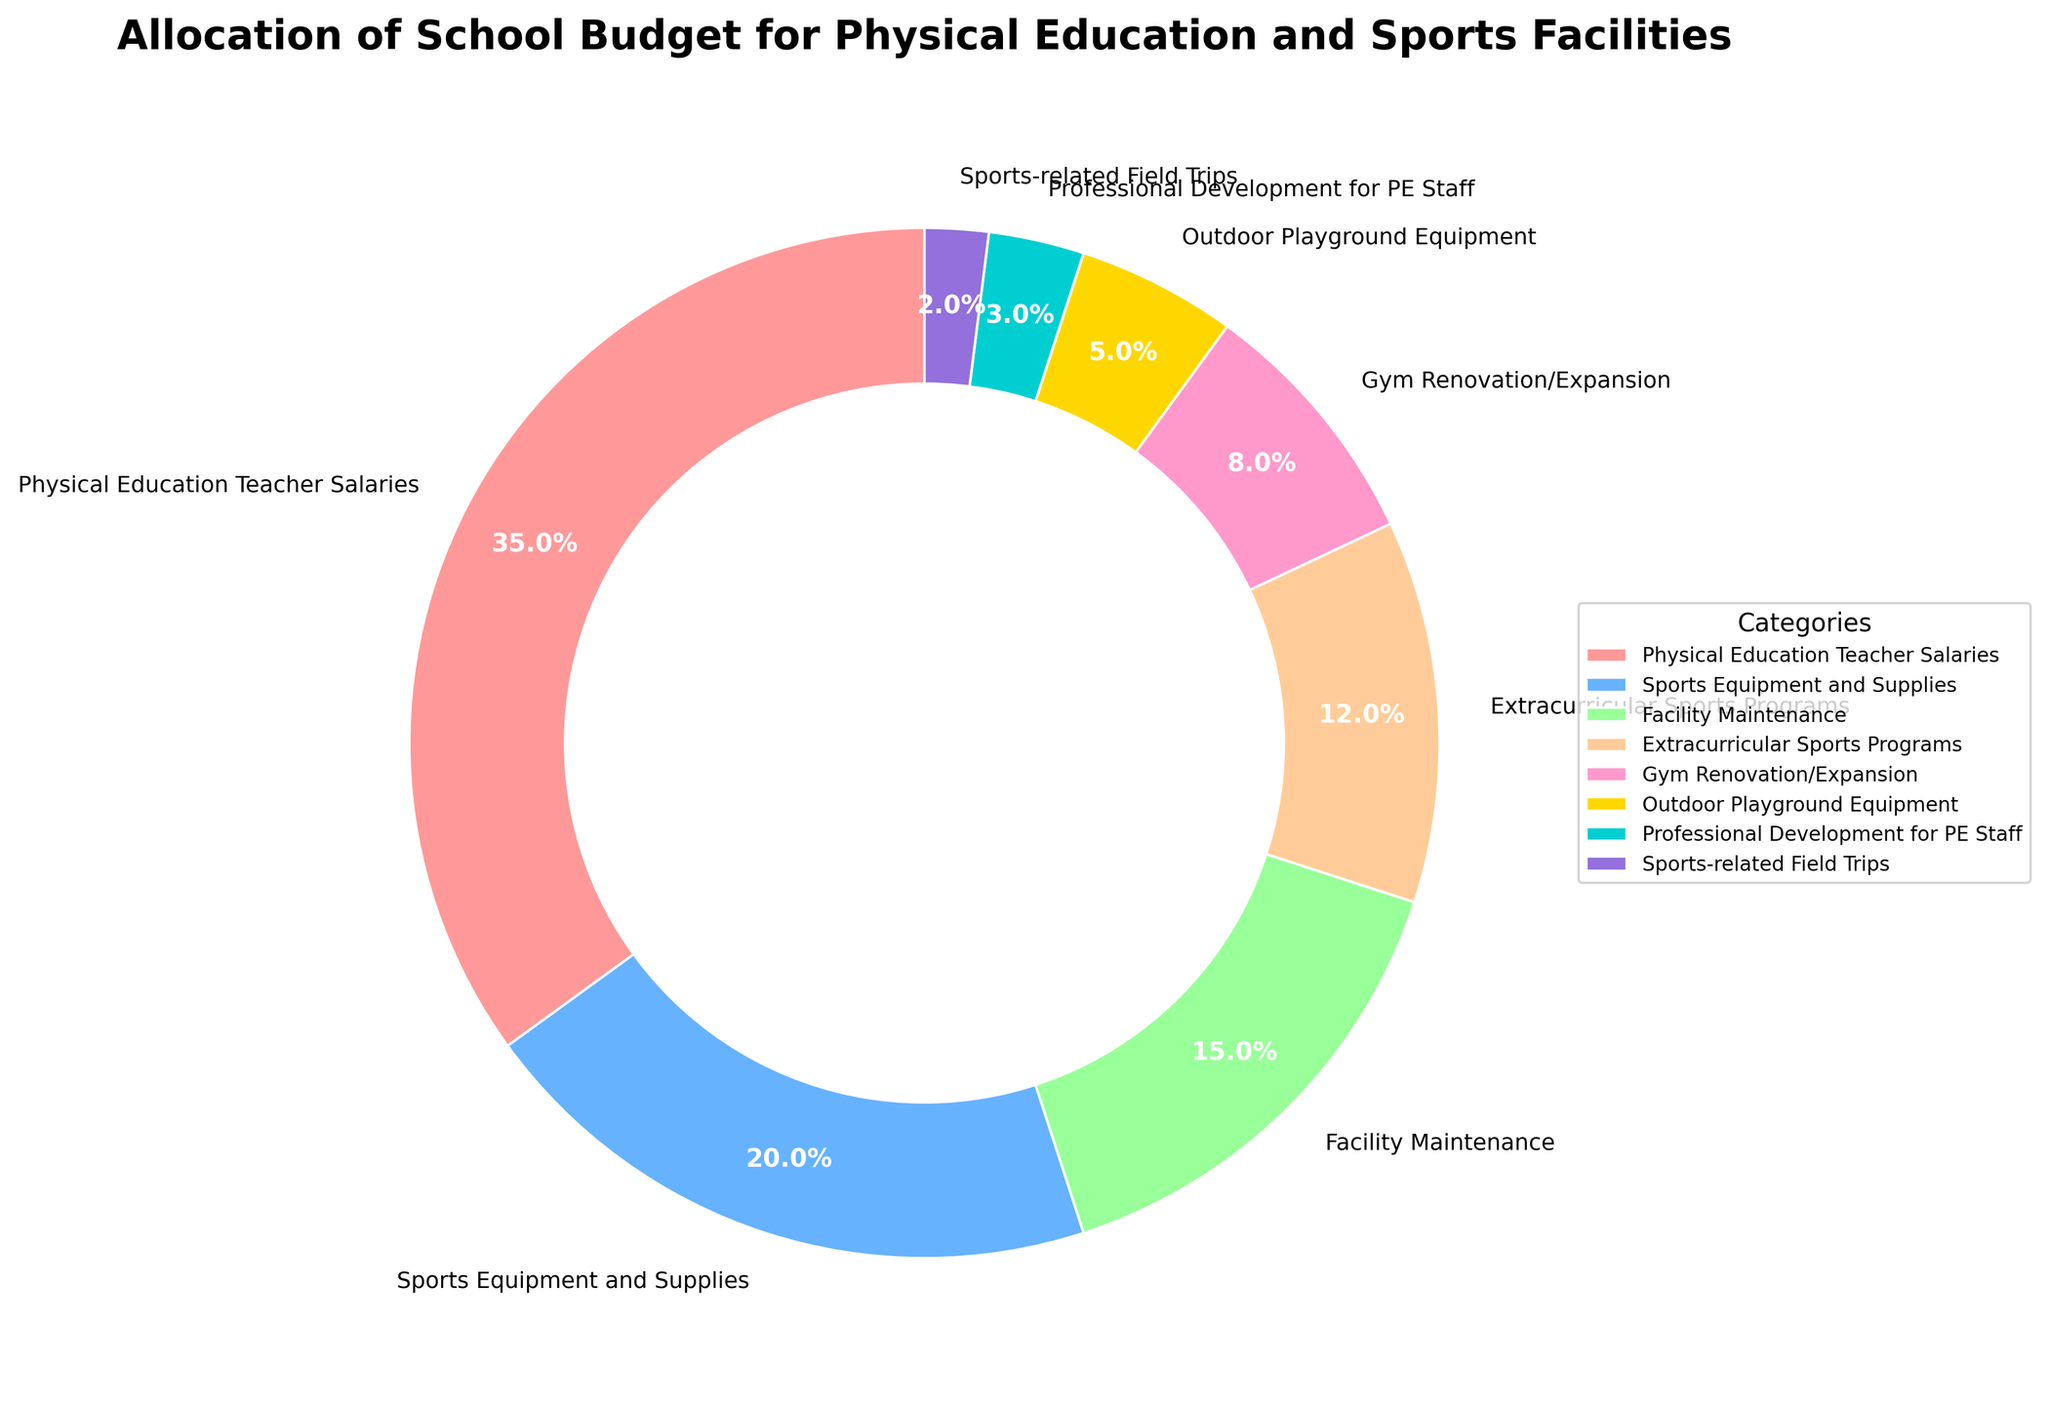What percentage of the budget is allocated to Physical Education Teacher Salaries and Sports Equipment and Supplies combined? The percentages for Physical Education Teacher Salaries and Sports Equipment and Supplies are 35% and 20%, respectively. Adding these together, 35% + 20% = 55%.
Answer: 55% Which category has a larger budget allocation: Facility Maintenance or Extracurricular Sports Programs? The percentage for Facility Maintenance is 15%, while for Extracurricular Sports Programs it is 12%. Since 15% is greater than 12%, Facility Maintenance has a larger budget allocation.
Answer: Facility Maintenance How much more percentage of the budget is allocated to Gym Renovation/Expansion compared to Outdoor Playground Equipment? Gym Renovation/Expansion is allocated 8%, and Outdoor Playground Equipment is allocated 5%. The difference is 8% - 5% = 3%.
Answer: 3% What is the smallest budget category and what percentage is allocated to it? The smallest budget category is Sports-related Field Trips, with a budget allocation of 2%.
Answer: Sports-related Field Trips, 2% Is the budget allocation for Professional Development for PE Staff greater than or equal to the allocation for Outdoor Playground Equipment? The budget for Professional Development for PE Staff is 3%, and for Outdoor Playground Equipment it is 5%. Since 3% is less than 5%, the allocation for Professional Development for PE Staff is not greater than or equal to Outdoor Playground Equipment.
Answer: No What percentage of the budget is allocated between the Gym Renovation/Expansion and Professional Development for PE Staff? The percentages for Gym Renovation/Expansion and Professional Development for PE Staff are 8% and 3%, respectively. Adding these together, 8% + 3% = 11%.
Answer: 11% How does the percentage allocated to Facility Maintenance compare with that allocated to Sports-related Field Trips? The percent allocation for Facility Maintenance is 15%, and for Sports-related Field Trips it is 2%. Since 15% is greater than 2%, the allocation for Facility Maintenance is higher.
Answer: Facility Maintenance, higher Which category appears in a light green color in the pie chart, and what percentage of the budget is allocated to it? Based on the color scheme described, the light green color (#99FF99) is assigned to Facility Maintenance. The percentage allocated to Facility Maintenance is 15%.
Answer: Facility Maintenance, 15% Which three categories combined have the highest total percentage of the budget? Physical Education Teacher Salaries (35%), Sports Equipment and Supplies (20%), and Facility Maintenance (15%) have the highest combined total. Adding them together, 35% + 20% + 15% = 70%.
Answer: Physical Education Teacher Salaries, Sports Equipment and Supplies, Facility Maintenance, 70% What is the total percentage of the budget allocated to both Extracurricular Sports Programs and Sports-related Field Trips together? The percentages for Extracurricular Sports Programs and Sports-related Field Trips are 12% and 2%, respectively. Adding them together, 12% + 2% = 14%.
Answer: 14% 